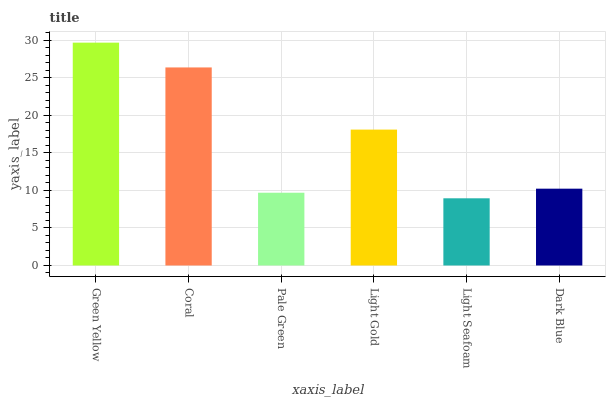Is Light Seafoam the minimum?
Answer yes or no. Yes. Is Green Yellow the maximum?
Answer yes or no. Yes. Is Coral the minimum?
Answer yes or no. No. Is Coral the maximum?
Answer yes or no. No. Is Green Yellow greater than Coral?
Answer yes or no. Yes. Is Coral less than Green Yellow?
Answer yes or no. Yes. Is Coral greater than Green Yellow?
Answer yes or no. No. Is Green Yellow less than Coral?
Answer yes or no. No. Is Light Gold the high median?
Answer yes or no. Yes. Is Dark Blue the low median?
Answer yes or no. Yes. Is Green Yellow the high median?
Answer yes or no. No. Is Pale Green the low median?
Answer yes or no. No. 